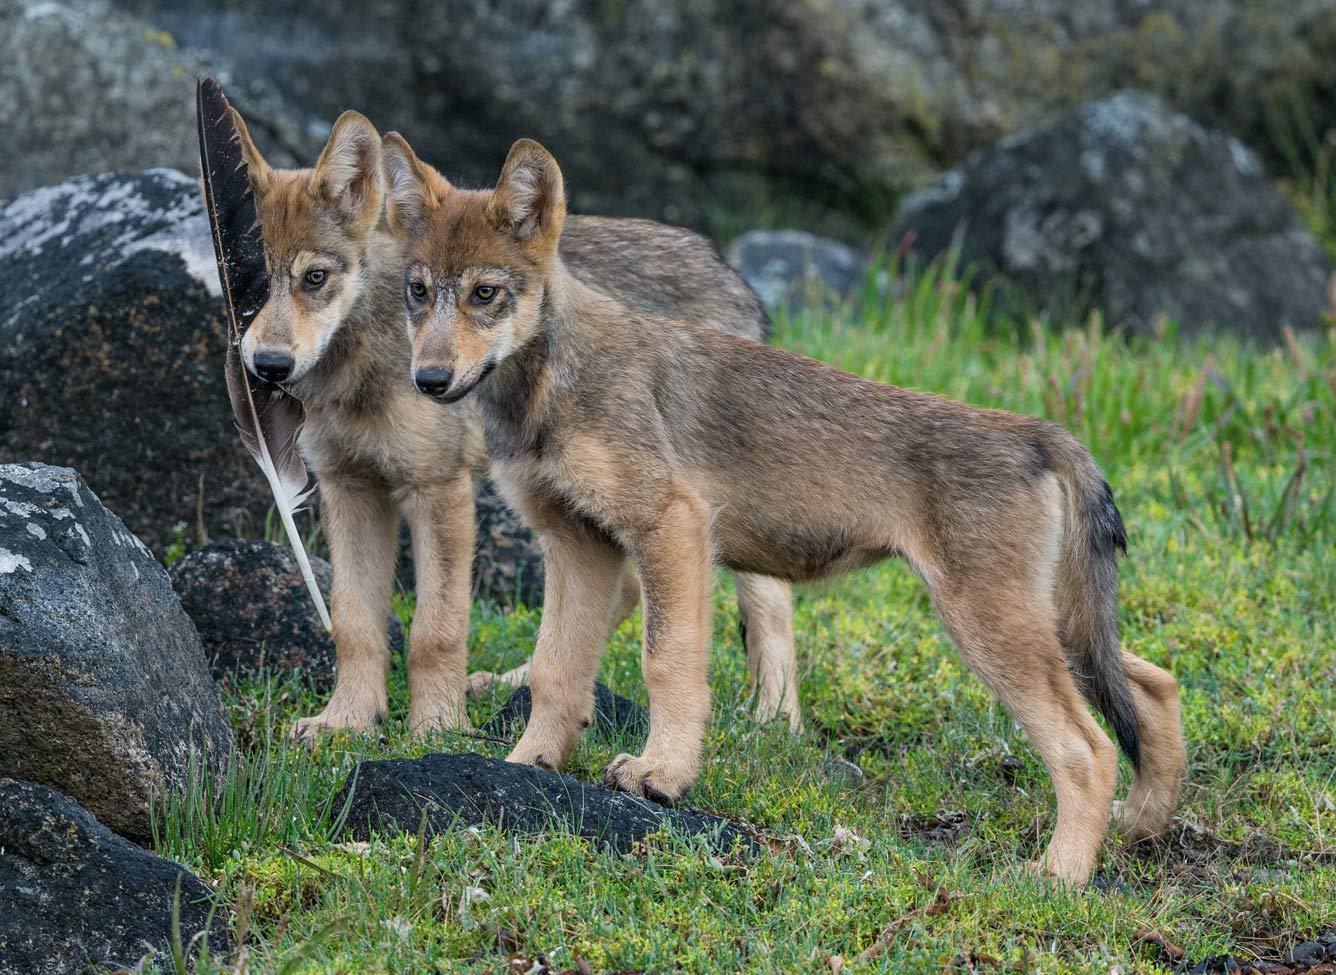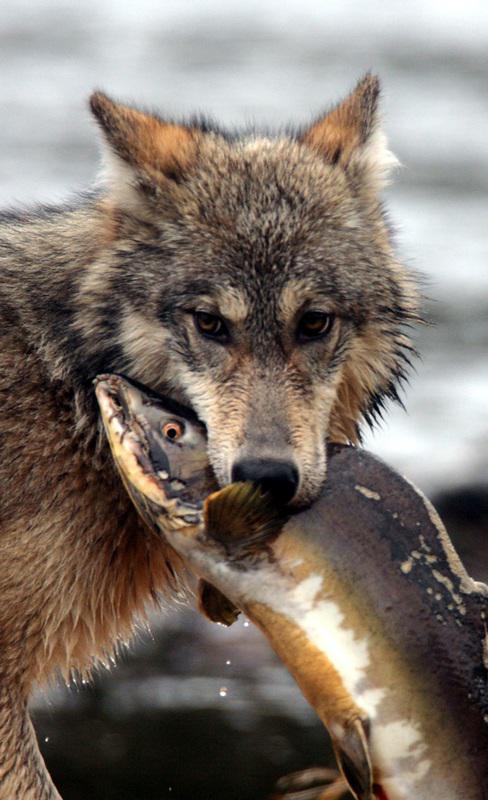The first image is the image on the left, the second image is the image on the right. Assess this claim about the two images: "There is a total of 1 adult wolf laying down.". Correct or not? Answer yes or no. No. The first image is the image on the left, the second image is the image on the right. Analyze the images presented: Is the assertion "A wolf is lying down in one picture and standing in the other." valid? Answer yes or no. No. 